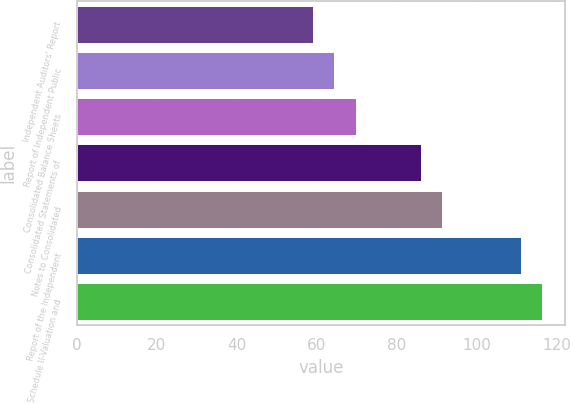<chart> <loc_0><loc_0><loc_500><loc_500><bar_chart><fcel>Independent Auditors' Report<fcel>Report of Independent Public<fcel>Consolidated Balance Sheets<fcel>Consolidated Statements of<fcel>Notes to Consolidated<fcel>Report of the Independent<fcel>Schedule II-Valuation and<nl><fcel>59<fcel>64.4<fcel>69.8<fcel>86<fcel>91.4<fcel>111<fcel>116.4<nl></chart> 